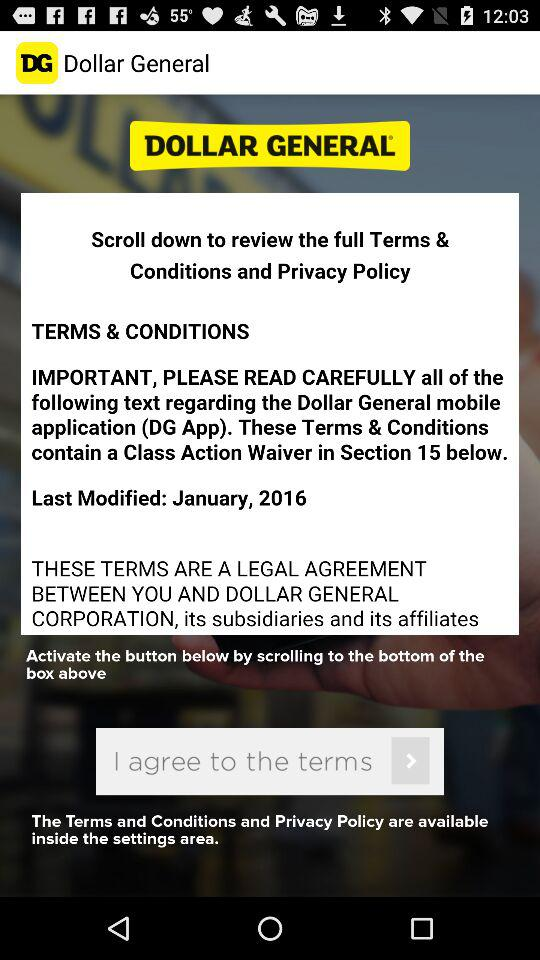What is the company name? The company name is Dollar General. 